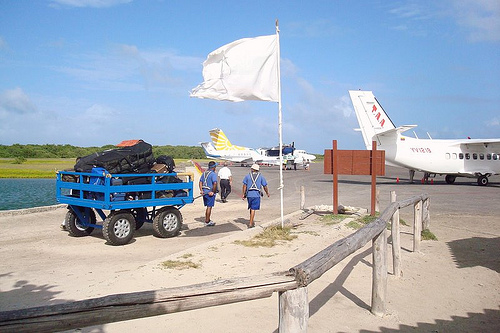Please transcribe the text in this image. TAA 